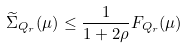<formula> <loc_0><loc_0><loc_500><loc_500>\widetilde { \Sigma } _ { Q _ { r } } ( \mu ) \leq \frac { 1 } { 1 + 2 \rho } F _ { Q _ { r } } ( \mu )</formula> 